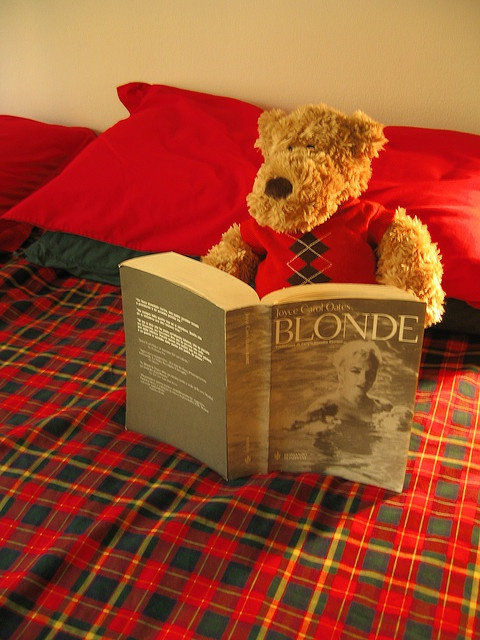Describe the objects in this image and their specific colors. I can see bed in tan, brown, maroon, red, and black tones, book in tan and olive tones, and teddy bear in tan, red, maroon, and orange tones in this image. 